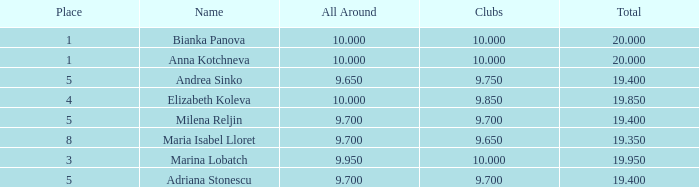How many places have bianka panova as the name, with clubs less than 10? 0.0. 